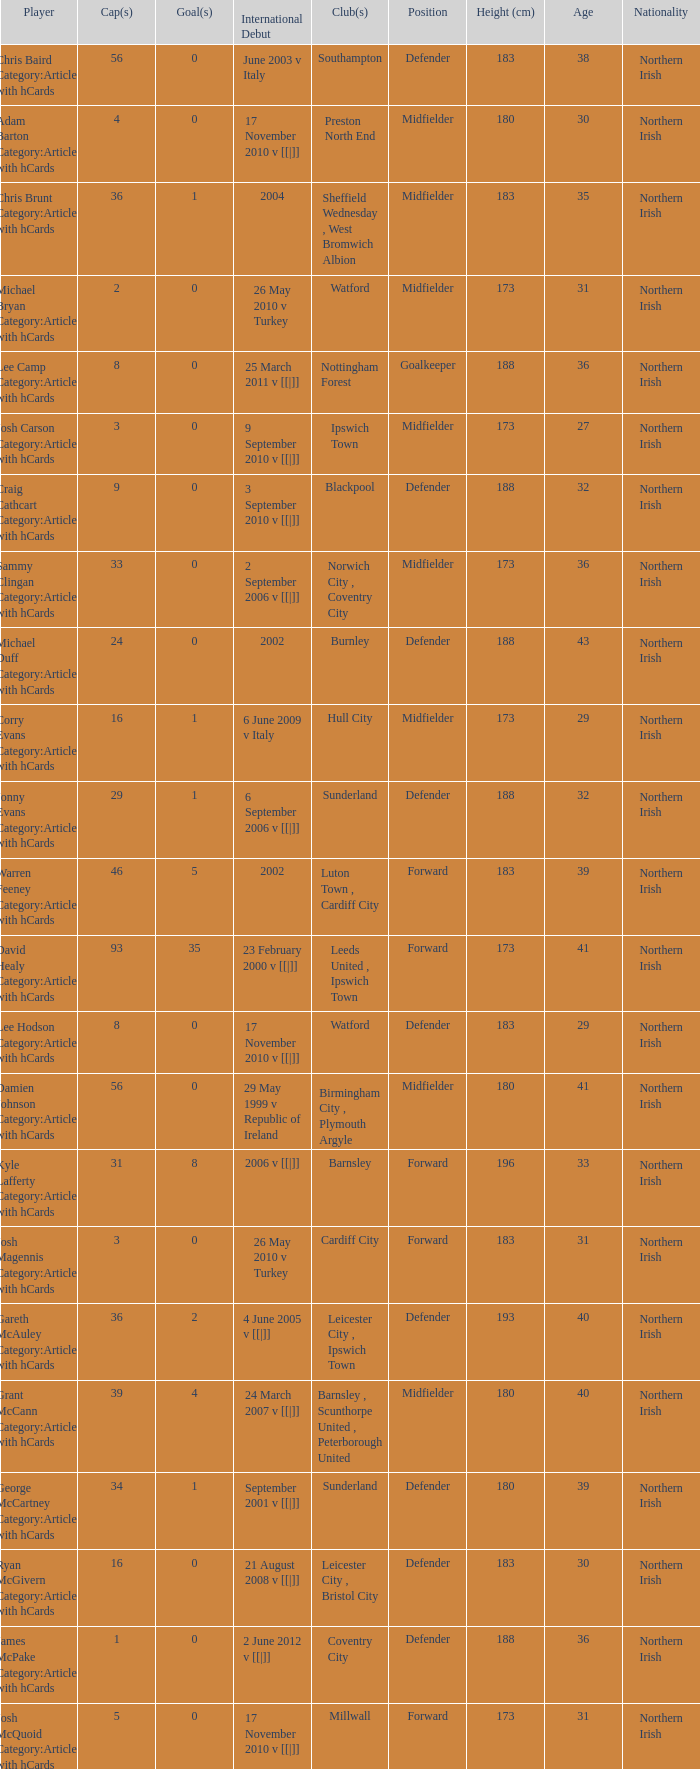How many caps figures are there for Norwich City, Coventry City? 1.0. 